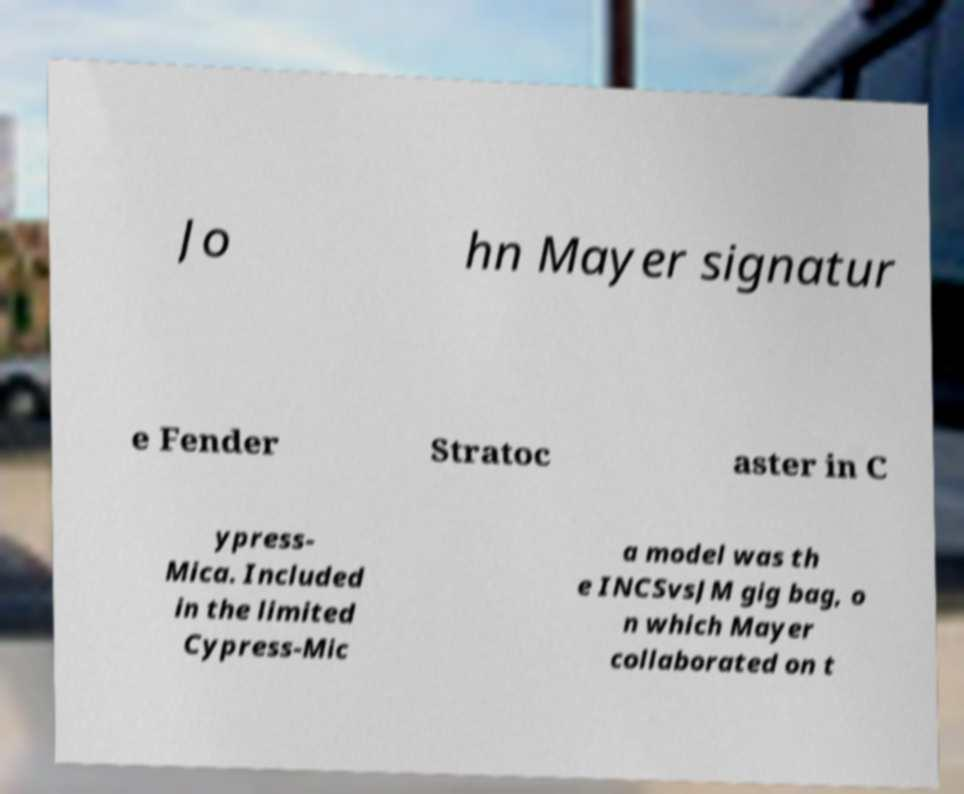There's text embedded in this image that I need extracted. Can you transcribe it verbatim? Jo hn Mayer signatur e Fender Stratoc aster in C ypress- Mica. Included in the limited Cypress-Mic a model was th e INCSvsJM gig bag, o n which Mayer collaborated on t 